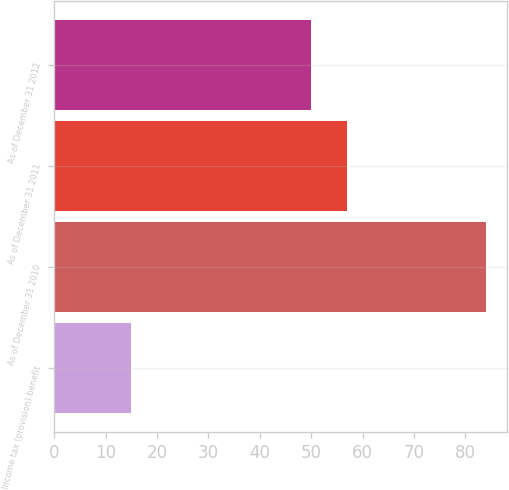Convert chart. <chart><loc_0><loc_0><loc_500><loc_500><bar_chart><fcel>Income tax (provision) benefit<fcel>As of December 31 2010<fcel>As of December 31 2011<fcel>As of December 31 2012<nl><fcel>15<fcel>84<fcel>57<fcel>50<nl></chart> 